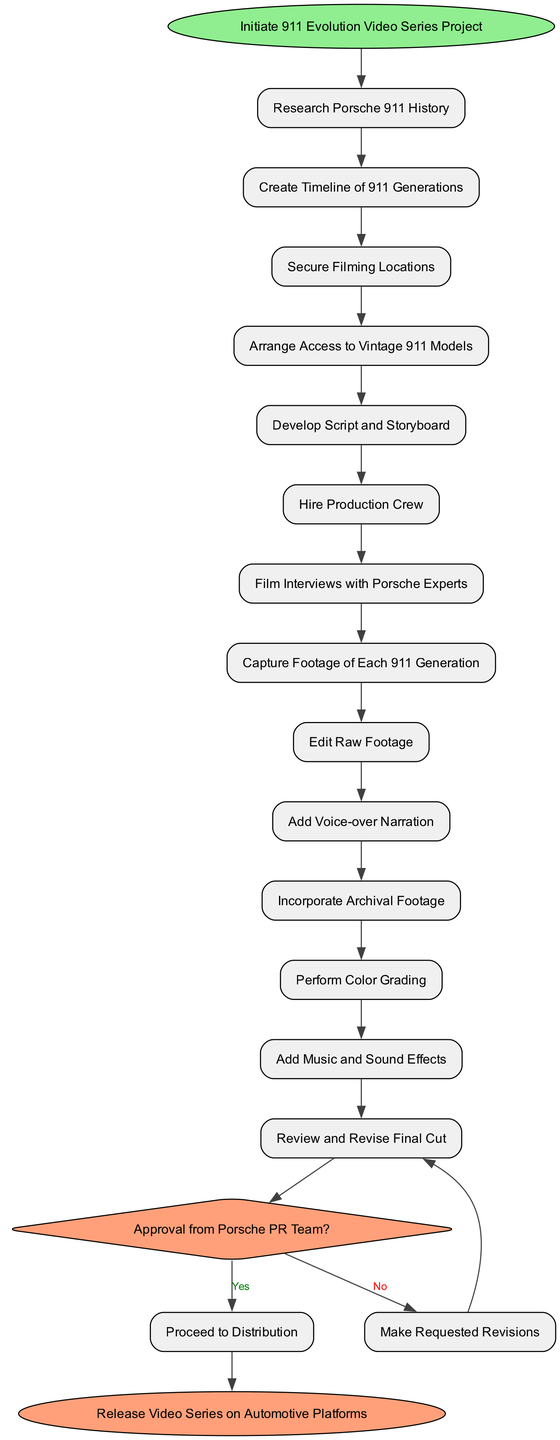What is the starting point of the video series production? The starting point is defined as the first node in the diagram, which is "Initiate 911 Evolution Video Series Project." This is clearly labeled at the beginning of the flowchart.
Answer: Initiate 911 Evolution Video Series Project How many activities are involved in the production process? The activities are listed as individual steps taken after the start node. Counting each activity in the list results in a total of 13 activities.
Answer: 13 What is the last activity before the decision node? The last activity before arriving at the decision node is "Review and Revise Final Cut." By tracing the edges backward from the decision node, we see that this is the immediate predecessor.
Answer: Review and Revise Final Cut What happens if the Porsche PR Team does not approve? According to the decision node, if the answer is "No," the process loops back to "Review and Revise Final Cut." This indicates that the team must address revisions before proceeding.
Answer: Make Requested Revisions Which activity follows "Film Interviews with Porsche Experts"? "Capture Footage of Each 911 Generation" is the direct successor to the activity "Film Interviews with Porsche Experts," which can be determined through the flow direction in the diagram.
Answer: Capture Footage of Each 911 Generation What is the end point of the video series production? The endpoint of the process, shown clearly as the last node in the diagram, is "Release Video Series on Automotive Platforms." This indicates the conclusion of the series production.
Answer: Release Video Series on Automotive Platforms How many decision nodes are present in this diagram? The diagram delineates a single decision node, as indicated by its diamond shape and the conditions listed. There are no other decision points present in the process flow.
Answer: 1 Which activity directly leads to the decision node? The activity "Incorporate Archival Footage" is the direct connection leading to the decision node, following the sequence of activities laid out in the diagram.
Answer: Incorporate Archival Footage What is the outcome if the decision node is answered positively? If answered with "Yes," the flow proceeds directly to "Release Video Series on Automotive Platforms," indicating the path taken upon receiving approval.
Answer: Proceed to Distribution 